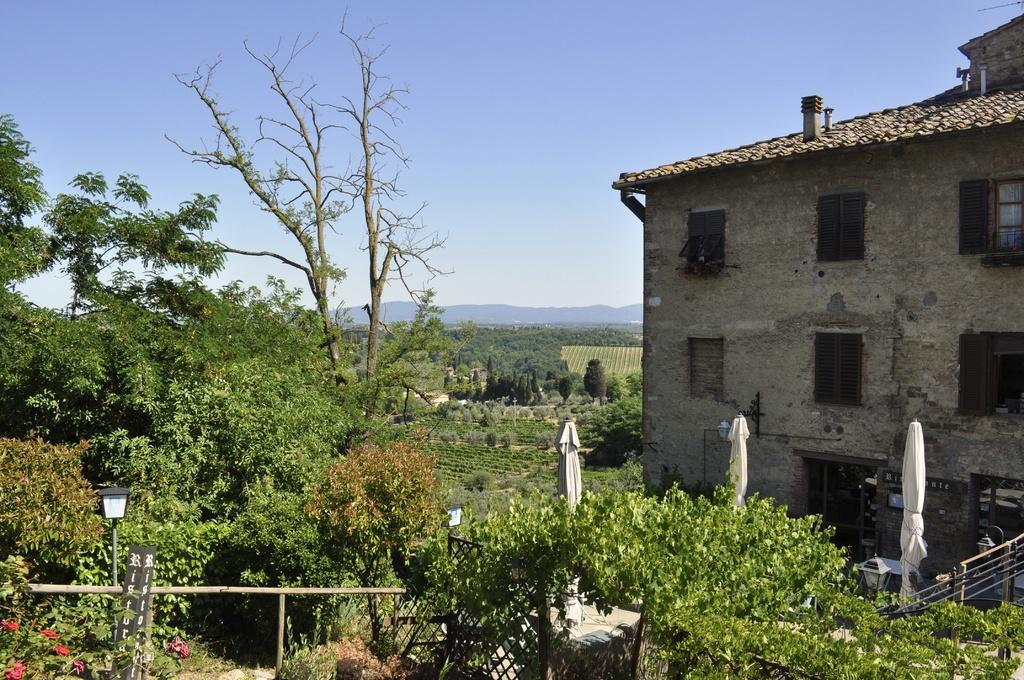What can be seen in the foreground of the image? In the foreground of the image, there are trees, a wooden railing, light poles, umbrellas folded, and a building. What is visible in the background of the image? In the background of the image, there is greenery, mountains, and the sky. Can you describe the vegetation in the foreground of the image? The vegetation in the foreground of the image consists of trees. What type of dress is being worn by the turkey in the image? There is no turkey present in the image, and therefore no dress can be associated with it. What type of land can be seen in the image? The image does not specifically show land, but it does depict trees, a wooden railing, light poles, umbrellas, a building, greenery, mountains, and the sky. 